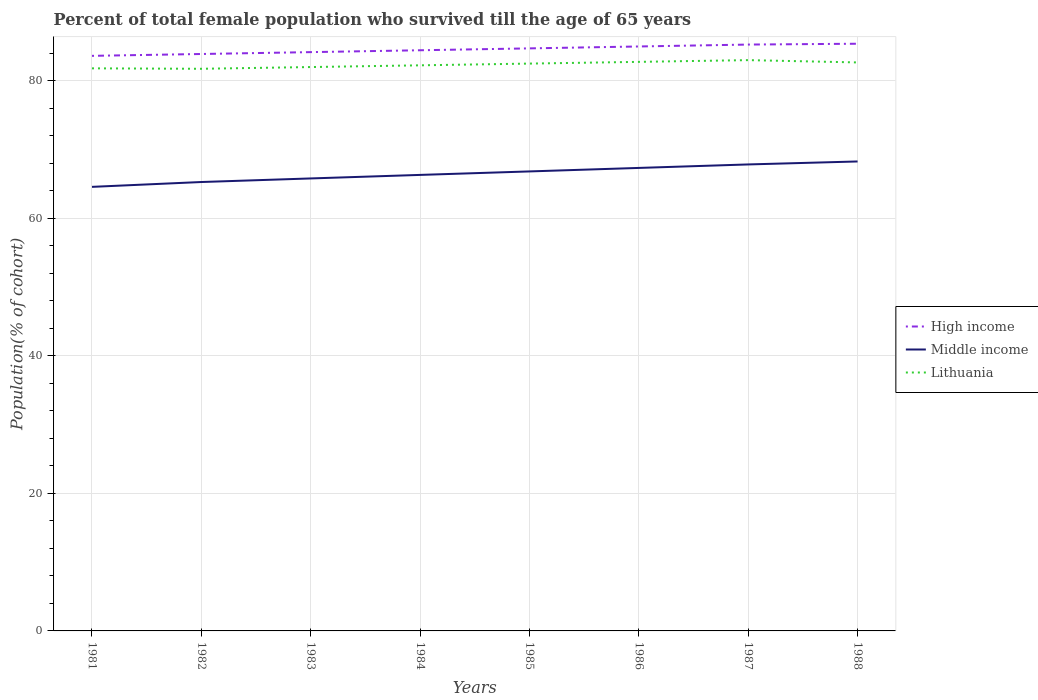Is the number of lines equal to the number of legend labels?
Provide a succinct answer. Yes. Across all years, what is the maximum percentage of total female population who survived till the age of 65 years in High income?
Your response must be concise. 83.59. What is the total percentage of total female population who survived till the age of 65 years in Lithuania in the graph?
Keep it short and to the point. -0.44. What is the difference between the highest and the second highest percentage of total female population who survived till the age of 65 years in High income?
Your answer should be compact. 1.76. What is the difference between the highest and the lowest percentage of total female population who survived till the age of 65 years in Middle income?
Ensure brevity in your answer.  4. Is the percentage of total female population who survived till the age of 65 years in Lithuania strictly greater than the percentage of total female population who survived till the age of 65 years in High income over the years?
Offer a terse response. Yes. How many years are there in the graph?
Provide a short and direct response. 8. What is the difference between two consecutive major ticks on the Y-axis?
Your answer should be compact. 20. Are the values on the major ticks of Y-axis written in scientific E-notation?
Give a very brief answer. No. Does the graph contain any zero values?
Make the answer very short. No. Does the graph contain grids?
Provide a short and direct response. Yes. Where does the legend appear in the graph?
Your answer should be very brief. Center right. How many legend labels are there?
Ensure brevity in your answer.  3. How are the legend labels stacked?
Provide a succinct answer. Vertical. What is the title of the graph?
Provide a succinct answer. Percent of total female population who survived till the age of 65 years. What is the label or title of the Y-axis?
Offer a terse response. Population(% of cohort). What is the Population(% of cohort) of High income in 1981?
Your answer should be very brief. 83.59. What is the Population(% of cohort) in Middle income in 1981?
Your response must be concise. 64.55. What is the Population(% of cohort) of Lithuania in 1981?
Provide a short and direct response. 81.77. What is the Population(% of cohort) in High income in 1982?
Your answer should be compact. 83.86. What is the Population(% of cohort) of Middle income in 1982?
Your answer should be very brief. 65.25. What is the Population(% of cohort) in Lithuania in 1982?
Make the answer very short. 81.71. What is the Population(% of cohort) of High income in 1983?
Offer a terse response. 84.13. What is the Population(% of cohort) of Middle income in 1983?
Provide a short and direct response. 65.77. What is the Population(% of cohort) in Lithuania in 1983?
Keep it short and to the point. 81.96. What is the Population(% of cohort) of High income in 1984?
Give a very brief answer. 84.4. What is the Population(% of cohort) in Middle income in 1984?
Give a very brief answer. 66.29. What is the Population(% of cohort) of Lithuania in 1984?
Your response must be concise. 82.22. What is the Population(% of cohort) in High income in 1985?
Your answer should be very brief. 84.68. What is the Population(% of cohort) of Middle income in 1985?
Make the answer very short. 66.79. What is the Population(% of cohort) in Lithuania in 1985?
Offer a terse response. 82.47. What is the Population(% of cohort) in High income in 1986?
Offer a very short reply. 84.96. What is the Population(% of cohort) of Middle income in 1986?
Provide a succinct answer. 67.3. What is the Population(% of cohort) of Lithuania in 1986?
Your answer should be very brief. 82.72. What is the Population(% of cohort) in High income in 1987?
Offer a terse response. 85.23. What is the Population(% of cohort) of Middle income in 1987?
Your answer should be compact. 67.81. What is the Population(% of cohort) in Lithuania in 1987?
Your answer should be compact. 82.97. What is the Population(% of cohort) in High income in 1988?
Your answer should be very brief. 85.35. What is the Population(% of cohort) in Middle income in 1988?
Provide a succinct answer. 68.24. What is the Population(% of cohort) of Lithuania in 1988?
Provide a short and direct response. 82.64. Across all years, what is the maximum Population(% of cohort) in High income?
Provide a succinct answer. 85.35. Across all years, what is the maximum Population(% of cohort) in Middle income?
Provide a short and direct response. 68.24. Across all years, what is the maximum Population(% of cohort) of Lithuania?
Offer a very short reply. 82.97. Across all years, what is the minimum Population(% of cohort) in High income?
Give a very brief answer. 83.59. Across all years, what is the minimum Population(% of cohort) of Middle income?
Make the answer very short. 64.55. Across all years, what is the minimum Population(% of cohort) of Lithuania?
Ensure brevity in your answer.  81.71. What is the total Population(% of cohort) in High income in the graph?
Give a very brief answer. 676.21. What is the total Population(% of cohort) in Middle income in the graph?
Give a very brief answer. 532. What is the total Population(% of cohort) in Lithuania in the graph?
Offer a terse response. 658.46. What is the difference between the Population(% of cohort) of High income in 1981 and that in 1982?
Keep it short and to the point. -0.27. What is the difference between the Population(% of cohort) in Middle income in 1981 and that in 1982?
Give a very brief answer. -0.7. What is the difference between the Population(% of cohort) of Lithuania in 1981 and that in 1982?
Provide a short and direct response. 0.06. What is the difference between the Population(% of cohort) of High income in 1981 and that in 1983?
Give a very brief answer. -0.54. What is the difference between the Population(% of cohort) in Middle income in 1981 and that in 1983?
Your answer should be compact. -1.23. What is the difference between the Population(% of cohort) of Lithuania in 1981 and that in 1983?
Provide a short and direct response. -0.19. What is the difference between the Population(% of cohort) of High income in 1981 and that in 1984?
Provide a short and direct response. -0.81. What is the difference between the Population(% of cohort) in Middle income in 1981 and that in 1984?
Keep it short and to the point. -1.74. What is the difference between the Population(% of cohort) in Lithuania in 1981 and that in 1984?
Make the answer very short. -0.44. What is the difference between the Population(% of cohort) of High income in 1981 and that in 1985?
Your answer should be very brief. -1.09. What is the difference between the Population(% of cohort) of Middle income in 1981 and that in 1985?
Make the answer very short. -2.24. What is the difference between the Population(% of cohort) in Lithuania in 1981 and that in 1985?
Ensure brevity in your answer.  -0.69. What is the difference between the Population(% of cohort) of High income in 1981 and that in 1986?
Your answer should be very brief. -1.36. What is the difference between the Population(% of cohort) in Middle income in 1981 and that in 1986?
Your response must be concise. -2.75. What is the difference between the Population(% of cohort) of Lithuania in 1981 and that in 1986?
Make the answer very short. -0.94. What is the difference between the Population(% of cohort) of High income in 1981 and that in 1987?
Keep it short and to the point. -1.64. What is the difference between the Population(% of cohort) of Middle income in 1981 and that in 1987?
Offer a very short reply. -3.26. What is the difference between the Population(% of cohort) in Lithuania in 1981 and that in 1987?
Offer a very short reply. -1.2. What is the difference between the Population(% of cohort) in High income in 1981 and that in 1988?
Your answer should be compact. -1.76. What is the difference between the Population(% of cohort) of Middle income in 1981 and that in 1988?
Provide a short and direct response. -3.69. What is the difference between the Population(% of cohort) in Lithuania in 1981 and that in 1988?
Your answer should be very brief. -0.86. What is the difference between the Population(% of cohort) of High income in 1982 and that in 1983?
Make the answer very short. -0.27. What is the difference between the Population(% of cohort) of Middle income in 1982 and that in 1983?
Provide a short and direct response. -0.52. What is the difference between the Population(% of cohort) in Lithuania in 1982 and that in 1983?
Provide a succinct answer. -0.25. What is the difference between the Population(% of cohort) in High income in 1982 and that in 1984?
Your response must be concise. -0.54. What is the difference between the Population(% of cohort) of Middle income in 1982 and that in 1984?
Your answer should be very brief. -1.03. What is the difference between the Population(% of cohort) of Lithuania in 1982 and that in 1984?
Provide a short and direct response. -0.5. What is the difference between the Population(% of cohort) in High income in 1982 and that in 1985?
Ensure brevity in your answer.  -0.82. What is the difference between the Population(% of cohort) of Middle income in 1982 and that in 1985?
Your answer should be very brief. -1.54. What is the difference between the Population(% of cohort) of Lithuania in 1982 and that in 1985?
Offer a terse response. -0.75. What is the difference between the Population(% of cohort) in High income in 1982 and that in 1986?
Your answer should be compact. -1.09. What is the difference between the Population(% of cohort) of Middle income in 1982 and that in 1986?
Make the answer very short. -2.05. What is the difference between the Population(% of cohort) of Lithuania in 1982 and that in 1986?
Keep it short and to the point. -1.01. What is the difference between the Population(% of cohort) of High income in 1982 and that in 1987?
Keep it short and to the point. -1.37. What is the difference between the Population(% of cohort) in Middle income in 1982 and that in 1987?
Your answer should be compact. -2.55. What is the difference between the Population(% of cohort) of Lithuania in 1982 and that in 1987?
Provide a short and direct response. -1.26. What is the difference between the Population(% of cohort) in High income in 1982 and that in 1988?
Provide a short and direct response. -1.49. What is the difference between the Population(% of cohort) of Middle income in 1982 and that in 1988?
Offer a terse response. -2.99. What is the difference between the Population(% of cohort) in Lithuania in 1982 and that in 1988?
Your answer should be compact. -0.92. What is the difference between the Population(% of cohort) in High income in 1983 and that in 1984?
Offer a terse response. -0.27. What is the difference between the Population(% of cohort) of Middle income in 1983 and that in 1984?
Ensure brevity in your answer.  -0.51. What is the difference between the Population(% of cohort) of Lithuania in 1983 and that in 1984?
Ensure brevity in your answer.  -0.25. What is the difference between the Population(% of cohort) in High income in 1983 and that in 1985?
Offer a terse response. -0.55. What is the difference between the Population(% of cohort) in Middle income in 1983 and that in 1985?
Give a very brief answer. -1.02. What is the difference between the Population(% of cohort) of Lithuania in 1983 and that in 1985?
Your answer should be very brief. -0.5. What is the difference between the Population(% of cohort) in High income in 1983 and that in 1986?
Your answer should be very brief. -0.82. What is the difference between the Population(% of cohort) of Middle income in 1983 and that in 1986?
Provide a succinct answer. -1.53. What is the difference between the Population(% of cohort) of Lithuania in 1983 and that in 1986?
Ensure brevity in your answer.  -0.75. What is the difference between the Population(% of cohort) in High income in 1983 and that in 1987?
Your answer should be compact. -1.1. What is the difference between the Population(% of cohort) of Middle income in 1983 and that in 1987?
Your answer should be compact. -2.03. What is the difference between the Population(% of cohort) of Lithuania in 1983 and that in 1987?
Offer a terse response. -1.01. What is the difference between the Population(% of cohort) of High income in 1983 and that in 1988?
Your answer should be very brief. -1.22. What is the difference between the Population(% of cohort) of Middle income in 1983 and that in 1988?
Offer a terse response. -2.47. What is the difference between the Population(% of cohort) in Lithuania in 1983 and that in 1988?
Your answer should be very brief. -0.67. What is the difference between the Population(% of cohort) in High income in 1984 and that in 1985?
Offer a terse response. -0.27. What is the difference between the Population(% of cohort) in Middle income in 1984 and that in 1985?
Make the answer very short. -0.51. What is the difference between the Population(% of cohort) in Lithuania in 1984 and that in 1985?
Your response must be concise. -0.25. What is the difference between the Population(% of cohort) in High income in 1984 and that in 1986?
Provide a short and direct response. -0.55. What is the difference between the Population(% of cohort) of Middle income in 1984 and that in 1986?
Make the answer very short. -1.02. What is the difference between the Population(% of cohort) in Lithuania in 1984 and that in 1986?
Your response must be concise. -0.5. What is the difference between the Population(% of cohort) in High income in 1984 and that in 1987?
Provide a succinct answer. -0.83. What is the difference between the Population(% of cohort) of Middle income in 1984 and that in 1987?
Ensure brevity in your answer.  -1.52. What is the difference between the Population(% of cohort) in Lithuania in 1984 and that in 1987?
Your answer should be compact. -0.75. What is the difference between the Population(% of cohort) in High income in 1984 and that in 1988?
Give a very brief answer. -0.95. What is the difference between the Population(% of cohort) in Middle income in 1984 and that in 1988?
Your answer should be compact. -1.96. What is the difference between the Population(% of cohort) of Lithuania in 1984 and that in 1988?
Your response must be concise. -0.42. What is the difference between the Population(% of cohort) in High income in 1985 and that in 1986?
Keep it short and to the point. -0.28. What is the difference between the Population(% of cohort) in Middle income in 1985 and that in 1986?
Ensure brevity in your answer.  -0.51. What is the difference between the Population(% of cohort) in Lithuania in 1985 and that in 1986?
Your response must be concise. -0.25. What is the difference between the Population(% of cohort) in High income in 1985 and that in 1987?
Your answer should be compact. -0.55. What is the difference between the Population(% of cohort) in Middle income in 1985 and that in 1987?
Your response must be concise. -1.01. What is the difference between the Population(% of cohort) of Lithuania in 1985 and that in 1987?
Your response must be concise. -0.5. What is the difference between the Population(% of cohort) in High income in 1985 and that in 1988?
Your response must be concise. -0.68. What is the difference between the Population(% of cohort) of Middle income in 1985 and that in 1988?
Ensure brevity in your answer.  -1.45. What is the difference between the Population(% of cohort) of Lithuania in 1985 and that in 1988?
Make the answer very short. -0.17. What is the difference between the Population(% of cohort) of High income in 1986 and that in 1987?
Offer a very short reply. -0.28. What is the difference between the Population(% of cohort) of Middle income in 1986 and that in 1987?
Your response must be concise. -0.5. What is the difference between the Population(% of cohort) of Lithuania in 1986 and that in 1987?
Your response must be concise. -0.25. What is the difference between the Population(% of cohort) in High income in 1986 and that in 1988?
Ensure brevity in your answer.  -0.4. What is the difference between the Population(% of cohort) in Middle income in 1986 and that in 1988?
Provide a short and direct response. -0.94. What is the difference between the Population(% of cohort) in Lithuania in 1986 and that in 1988?
Give a very brief answer. 0.08. What is the difference between the Population(% of cohort) of High income in 1987 and that in 1988?
Keep it short and to the point. -0.12. What is the difference between the Population(% of cohort) of Middle income in 1987 and that in 1988?
Provide a short and direct response. -0.43. What is the difference between the Population(% of cohort) in Lithuania in 1987 and that in 1988?
Ensure brevity in your answer.  0.33. What is the difference between the Population(% of cohort) of High income in 1981 and the Population(% of cohort) of Middle income in 1982?
Your answer should be compact. 18.34. What is the difference between the Population(% of cohort) of High income in 1981 and the Population(% of cohort) of Lithuania in 1982?
Offer a very short reply. 1.88. What is the difference between the Population(% of cohort) in Middle income in 1981 and the Population(% of cohort) in Lithuania in 1982?
Make the answer very short. -17.16. What is the difference between the Population(% of cohort) in High income in 1981 and the Population(% of cohort) in Middle income in 1983?
Make the answer very short. 17.82. What is the difference between the Population(% of cohort) in High income in 1981 and the Population(% of cohort) in Lithuania in 1983?
Your answer should be very brief. 1.63. What is the difference between the Population(% of cohort) of Middle income in 1981 and the Population(% of cohort) of Lithuania in 1983?
Offer a terse response. -17.42. What is the difference between the Population(% of cohort) of High income in 1981 and the Population(% of cohort) of Middle income in 1984?
Offer a very short reply. 17.31. What is the difference between the Population(% of cohort) of High income in 1981 and the Population(% of cohort) of Lithuania in 1984?
Your answer should be compact. 1.38. What is the difference between the Population(% of cohort) in Middle income in 1981 and the Population(% of cohort) in Lithuania in 1984?
Provide a succinct answer. -17.67. What is the difference between the Population(% of cohort) of High income in 1981 and the Population(% of cohort) of Middle income in 1985?
Your answer should be compact. 16.8. What is the difference between the Population(% of cohort) in High income in 1981 and the Population(% of cohort) in Lithuania in 1985?
Ensure brevity in your answer.  1.13. What is the difference between the Population(% of cohort) in Middle income in 1981 and the Population(% of cohort) in Lithuania in 1985?
Keep it short and to the point. -17.92. What is the difference between the Population(% of cohort) in High income in 1981 and the Population(% of cohort) in Middle income in 1986?
Ensure brevity in your answer.  16.29. What is the difference between the Population(% of cohort) of High income in 1981 and the Population(% of cohort) of Lithuania in 1986?
Give a very brief answer. 0.87. What is the difference between the Population(% of cohort) of Middle income in 1981 and the Population(% of cohort) of Lithuania in 1986?
Ensure brevity in your answer.  -18.17. What is the difference between the Population(% of cohort) in High income in 1981 and the Population(% of cohort) in Middle income in 1987?
Offer a very short reply. 15.79. What is the difference between the Population(% of cohort) in High income in 1981 and the Population(% of cohort) in Lithuania in 1987?
Make the answer very short. 0.62. What is the difference between the Population(% of cohort) of Middle income in 1981 and the Population(% of cohort) of Lithuania in 1987?
Ensure brevity in your answer.  -18.42. What is the difference between the Population(% of cohort) in High income in 1981 and the Population(% of cohort) in Middle income in 1988?
Your response must be concise. 15.35. What is the difference between the Population(% of cohort) in High income in 1981 and the Population(% of cohort) in Lithuania in 1988?
Keep it short and to the point. 0.96. What is the difference between the Population(% of cohort) in Middle income in 1981 and the Population(% of cohort) in Lithuania in 1988?
Provide a succinct answer. -18.09. What is the difference between the Population(% of cohort) in High income in 1982 and the Population(% of cohort) in Middle income in 1983?
Keep it short and to the point. 18.09. What is the difference between the Population(% of cohort) of High income in 1982 and the Population(% of cohort) of Lithuania in 1983?
Provide a succinct answer. 1.9. What is the difference between the Population(% of cohort) in Middle income in 1982 and the Population(% of cohort) in Lithuania in 1983?
Provide a succinct answer. -16.71. What is the difference between the Population(% of cohort) of High income in 1982 and the Population(% of cohort) of Middle income in 1984?
Offer a terse response. 17.58. What is the difference between the Population(% of cohort) in High income in 1982 and the Population(% of cohort) in Lithuania in 1984?
Give a very brief answer. 1.65. What is the difference between the Population(% of cohort) of Middle income in 1982 and the Population(% of cohort) of Lithuania in 1984?
Your answer should be very brief. -16.96. What is the difference between the Population(% of cohort) of High income in 1982 and the Population(% of cohort) of Middle income in 1985?
Your response must be concise. 17.07. What is the difference between the Population(% of cohort) of High income in 1982 and the Population(% of cohort) of Lithuania in 1985?
Your response must be concise. 1.39. What is the difference between the Population(% of cohort) in Middle income in 1982 and the Population(% of cohort) in Lithuania in 1985?
Keep it short and to the point. -17.21. What is the difference between the Population(% of cohort) of High income in 1982 and the Population(% of cohort) of Middle income in 1986?
Ensure brevity in your answer.  16.56. What is the difference between the Population(% of cohort) of High income in 1982 and the Population(% of cohort) of Lithuania in 1986?
Your answer should be compact. 1.14. What is the difference between the Population(% of cohort) in Middle income in 1982 and the Population(% of cohort) in Lithuania in 1986?
Your answer should be very brief. -17.47. What is the difference between the Population(% of cohort) in High income in 1982 and the Population(% of cohort) in Middle income in 1987?
Your answer should be compact. 16.05. What is the difference between the Population(% of cohort) in High income in 1982 and the Population(% of cohort) in Lithuania in 1987?
Offer a terse response. 0.89. What is the difference between the Population(% of cohort) in Middle income in 1982 and the Population(% of cohort) in Lithuania in 1987?
Keep it short and to the point. -17.72. What is the difference between the Population(% of cohort) in High income in 1982 and the Population(% of cohort) in Middle income in 1988?
Ensure brevity in your answer.  15.62. What is the difference between the Population(% of cohort) in High income in 1982 and the Population(% of cohort) in Lithuania in 1988?
Provide a succinct answer. 1.23. What is the difference between the Population(% of cohort) of Middle income in 1982 and the Population(% of cohort) of Lithuania in 1988?
Your response must be concise. -17.38. What is the difference between the Population(% of cohort) in High income in 1983 and the Population(% of cohort) in Middle income in 1984?
Offer a very short reply. 17.85. What is the difference between the Population(% of cohort) in High income in 1983 and the Population(% of cohort) in Lithuania in 1984?
Ensure brevity in your answer.  1.92. What is the difference between the Population(% of cohort) in Middle income in 1983 and the Population(% of cohort) in Lithuania in 1984?
Your response must be concise. -16.44. What is the difference between the Population(% of cohort) of High income in 1983 and the Population(% of cohort) of Middle income in 1985?
Keep it short and to the point. 17.34. What is the difference between the Population(% of cohort) in High income in 1983 and the Population(% of cohort) in Lithuania in 1985?
Keep it short and to the point. 1.67. What is the difference between the Population(% of cohort) of Middle income in 1983 and the Population(% of cohort) of Lithuania in 1985?
Offer a terse response. -16.69. What is the difference between the Population(% of cohort) of High income in 1983 and the Population(% of cohort) of Middle income in 1986?
Ensure brevity in your answer.  16.83. What is the difference between the Population(% of cohort) in High income in 1983 and the Population(% of cohort) in Lithuania in 1986?
Keep it short and to the point. 1.41. What is the difference between the Population(% of cohort) of Middle income in 1983 and the Population(% of cohort) of Lithuania in 1986?
Your answer should be very brief. -16.95. What is the difference between the Population(% of cohort) in High income in 1983 and the Population(% of cohort) in Middle income in 1987?
Give a very brief answer. 16.33. What is the difference between the Population(% of cohort) in High income in 1983 and the Population(% of cohort) in Lithuania in 1987?
Make the answer very short. 1.16. What is the difference between the Population(% of cohort) in Middle income in 1983 and the Population(% of cohort) in Lithuania in 1987?
Ensure brevity in your answer.  -17.2. What is the difference between the Population(% of cohort) of High income in 1983 and the Population(% of cohort) of Middle income in 1988?
Your response must be concise. 15.89. What is the difference between the Population(% of cohort) of High income in 1983 and the Population(% of cohort) of Lithuania in 1988?
Offer a very short reply. 1.5. What is the difference between the Population(% of cohort) in Middle income in 1983 and the Population(% of cohort) in Lithuania in 1988?
Provide a short and direct response. -16.86. What is the difference between the Population(% of cohort) of High income in 1984 and the Population(% of cohort) of Middle income in 1985?
Offer a very short reply. 17.61. What is the difference between the Population(% of cohort) in High income in 1984 and the Population(% of cohort) in Lithuania in 1985?
Keep it short and to the point. 1.94. What is the difference between the Population(% of cohort) in Middle income in 1984 and the Population(% of cohort) in Lithuania in 1985?
Provide a succinct answer. -16.18. What is the difference between the Population(% of cohort) in High income in 1984 and the Population(% of cohort) in Middle income in 1986?
Offer a very short reply. 17.1. What is the difference between the Population(% of cohort) in High income in 1984 and the Population(% of cohort) in Lithuania in 1986?
Make the answer very short. 1.69. What is the difference between the Population(% of cohort) of Middle income in 1984 and the Population(% of cohort) of Lithuania in 1986?
Offer a very short reply. -16.43. What is the difference between the Population(% of cohort) of High income in 1984 and the Population(% of cohort) of Middle income in 1987?
Your answer should be compact. 16.6. What is the difference between the Population(% of cohort) in High income in 1984 and the Population(% of cohort) in Lithuania in 1987?
Make the answer very short. 1.43. What is the difference between the Population(% of cohort) in Middle income in 1984 and the Population(% of cohort) in Lithuania in 1987?
Your answer should be compact. -16.68. What is the difference between the Population(% of cohort) of High income in 1984 and the Population(% of cohort) of Middle income in 1988?
Your response must be concise. 16.16. What is the difference between the Population(% of cohort) in High income in 1984 and the Population(% of cohort) in Lithuania in 1988?
Your answer should be compact. 1.77. What is the difference between the Population(% of cohort) in Middle income in 1984 and the Population(% of cohort) in Lithuania in 1988?
Your answer should be very brief. -16.35. What is the difference between the Population(% of cohort) in High income in 1985 and the Population(% of cohort) in Middle income in 1986?
Offer a terse response. 17.38. What is the difference between the Population(% of cohort) of High income in 1985 and the Population(% of cohort) of Lithuania in 1986?
Keep it short and to the point. 1.96. What is the difference between the Population(% of cohort) of Middle income in 1985 and the Population(% of cohort) of Lithuania in 1986?
Ensure brevity in your answer.  -15.93. What is the difference between the Population(% of cohort) in High income in 1985 and the Population(% of cohort) in Middle income in 1987?
Your response must be concise. 16.87. What is the difference between the Population(% of cohort) in High income in 1985 and the Population(% of cohort) in Lithuania in 1987?
Ensure brevity in your answer.  1.71. What is the difference between the Population(% of cohort) of Middle income in 1985 and the Population(% of cohort) of Lithuania in 1987?
Your response must be concise. -16.18. What is the difference between the Population(% of cohort) in High income in 1985 and the Population(% of cohort) in Middle income in 1988?
Your response must be concise. 16.44. What is the difference between the Population(% of cohort) of High income in 1985 and the Population(% of cohort) of Lithuania in 1988?
Provide a succinct answer. 2.04. What is the difference between the Population(% of cohort) in Middle income in 1985 and the Population(% of cohort) in Lithuania in 1988?
Provide a succinct answer. -15.84. What is the difference between the Population(% of cohort) in High income in 1986 and the Population(% of cohort) in Middle income in 1987?
Provide a succinct answer. 17.15. What is the difference between the Population(% of cohort) of High income in 1986 and the Population(% of cohort) of Lithuania in 1987?
Offer a terse response. 1.98. What is the difference between the Population(% of cohort) of Middle income in 1986 and the Population(% of cohort) of Lithuania in 1987?
Provide a succinct answer. -15.67. What is the difference between the Population(% of cohort) in High income in 1986 and the Population(% of cohort) in Middle income in 1988?
Offer a terse response. 16.71. What is the difference between the Population(% of cohort) of High income in 1986 and the Population(% of cohort) of Lithuania in 1988?
Your answer should be compact. 2.32. What is the difference between the Population(% of cohort) of Middle income in 1986 and the Population(% of cohort) of Lithuania in 1988?
Your response must be concise. -15.33. What is the difference between the Population(% of cohort) of High income in 1987 and the Population(% of cohort) of Middle income in 1988?
Keep it short and to the point. 16.99. What is the difference between the Population(% of cohort) in High income in 1987 and the Population(% of cohort) in Lithuania in 1988?
Ensure brevity in your answer.  2.6. What is the difference between the Population(% of cohort) of Middle income in 1987 and the Population(% of cohort) of Lithuania in 1988?
Your answer should be compact. -14.83. What is the average Population(% of cohort) of High income per year?
Provide a short and direct response. 84.53. What is the average Population(% of cohort) of Middle income per year?
Offer a very short reply. 66.5. What is the average Population(% of cohort) in Lithuania per year?
Give a very brief answer. 82.31. In the year 1981, what is the difference between the Population(% of cohort) in High income and Population(% of cohort) in Middle income?
Provide a short and direct response. 19.04. In the year 1981, what is the difference between the Population(% of cohort) in High income and Population(% of cohort) in Lithuania?
Provide a succinct answer. 1.82. In the year 1981, what is the difference between the Population(% of cohort) of Middle income and Population(% of cohort) of Lithuania?
Provide a succinct answer. -17.23. In the year 1982, what is the difference between the Population(% of cohort) in High income and Population(% of cohort) in Middle income?
Make the answer very short. 18.61. In the year 1982, what is the difference between the Population(% of cohort) of High income and Population(% of cohort) of Lithuania?
Your answer should be very brief. 2.15. In the year 1982, what is the difference between the Population(% of cohort) in Middle income and Population(% of cohort) in Lithuania?
Make the answer very short. -16.46. In the year 1983, what is the difference between the Population(% of cohort) of High income and Population(% of cohort) of Middle income?
Provide a succinct answer. 18.36. In the year 1983, what is the difference between the Population(% of cohort) in High income and Population(% of cohort) in Lithuania?
Provide a short and direct response. 2.17. In the year 1983, what is the difference between the Population(% of cohort) in Middle income and Population(% of cohort) in Lithuania?
Offer a terse response. -16.19. In the year 1984, what is the difference between the Population(% of cohort) of High income and Population(% of cohort) of Middle income?
Provide a succinct answer. 18.12. In the year 1984, what is the difference between the Population(% of cohort) in High income and Population(% of cohort) in Lithuania?
Your answer should be very brief. 2.19. In the year 1984, what is the difference between the Population(% of cohort) in Middle income and Population(% of cohort) in Lithuania?
Offer a terse response. -15.93. In the year 1985, what is the difference between the Population(% of cohort) in High income and Population(% of cohort) in Middle income?
Provide a short and direct response. 17.89. In the year 1985, what is the difference between the Population(% of cohort) of High income and Population(% of cohort) of Lithuania?
Offer a very short reply. 2.21. In the year 1985, what is the difference between the Population(% of cohort) of Middle income and Population(% of cohort) of Lithuania?
Offer a very short reply. -15.67. In the year 1986, what is the difference between the Population(% of cohort) in High income and Population(% of cohort) in Middle income?
Provide a short and direct response. 17.65. In the year 1986, what is the difference between the Population(% of cohort) in High income and Population(% of cohort) in Lithuania?
Provide a short and direct response. 2.24. In the year 1986, what is the difference between the Population(% of cohort) of Middle income and Population(% of cohort) of Lithuania?
Provide a succinct answer. -15.42. In the year 1987, what is the difference between the Population(% of cohort) of High income and Population(% of cohort) of Middle income?
Give a very brief answer. 17.43. In the year 1987, what is the difference between the Population(% of cohort) in High income and Population(% of cohort) in Lithuania?
Keep it short and to the point. 2.26. In the year 1987, what is the difference between the Population(% of cohort) of Middle income and Population(% of cohort) of Lithuania?
Offer a terse response. -15.16. In the year 1988, what is the difference between the Population(% of cohort) of High income and Population(% of cohort) of Middle income?
Provide a succinct answer. 17.11. In the year 1988, what is the difference between the Population(% of cohort) of High income and Population(% of cohort) of Lithuania?
Make the answer very short. 2.72. In the year 1988, what is the difference between the Population(% of cohort) in Middle income and Population(% of cohort) in Lithuania?
Provide a succinct answer. -14.39. What is the ratio of the Population(% of cohort) of High income in 1981 to that in 1982?
Your response must be concise. 1. What is the ratio of the Population(% of cohort) in Middle income in 1981 to that in 1982?
Make the answer very short. 0.99. What is the ratio of the Population(% of cohort) of Lithuania in 1981 to that in 1982?
Provide a succinct answer. 1. What is the ratio of the Population(% of cohort) of High income in 1981 to that in 1983?
Offer a very short reply. 0.99. What is the ratio of the Population(% of cohort) in Middle income in 1981 to that in 1983?
Your answer should be very brief. 0.98. What is the ratio of the Population(% of cohort) in Middle income in 1981 to that in 1984?
Ensure brevity in your answer.  0.97. What is the ratio of the Population(% of cohort) in Lithuania in 1981 to that in 1984?
Offer a very short reply. 0.99. What is the ratio of the Population(% of cohort) in High income in 1981 to that in 1985?
Keep it short and to the point. 0.99. What is the ratio of the Population(% of cohort) of Middle income in 1981 to that in 1985?
Ensure brevity in your answer.  0.97. What is the ratio of the Population(% of cohort) in Middle income in 1981 to that in 1986?
Your answer should be compact. 0.96. What is the ratio of the Population(% of cohort) in Lithuania in 1981 to that in 1986?
Offer a very short reply. 0.99. What is the ratio of the Population(% of cohort) of High income in 1981 to that in 1987?
Your answer should be very brief. 0.98. What is the ratio of the Population(% of cohort) in Middle income in 1981 to that in 1987?
Provide a succinct answer. 0.95. What is the ratio of the Population(% of cohort) of Lithuania in 1981 to that in 1987?
Provide a succinct answer. 0.99. What is the ratio of the Population(% of cohort) of High income in 1981 to that in 1988?
Offer a very short reply. 0.98. What is the ratio of the Population(% of cohort) in Middle income in 1981 to that in 1988?
Offer a terse response. 0.95. What is the ratio of the Population(% of cohort) of Lithuania in 1981 to that in 1988?
Give a very brief answer. 0.99. What is the ratio of the Population(% of cohort) in Middle income in 1982 to that in 1983?
Provide a short and direct response. 0.99. What is the ratio of the Population(% of cohort) in Middle income in 1982 to that in 1984?
Provide a short and direct response. 0.98. What is the ratio of the Population(% of cohort) of Lithuania in 1982 to that in 1985?
Provide a short and direct response. 0.99. What is the ratio of the Population(% of cohort) in High income in 1982 to that in 1986?
Make the answer very short. 0.99. What is the ratio of the Population(% of cohort) of Middle income in 1982 to that in 1986?
Ensure brevity in your answer.  0.97. What is the ratio of the Population(% of cohort) of High income in 1982 to that in 1987?
Offer a very short reply. 0.98. What is the ratio of the Population(% of cohort) of Middle income in 1982 to that in 1987?
Your answer should be compact. 0.96. What is the ratio of the Population(% of cohort) in Lithuania in 1982 to that in 1987?
Give a very brief answer. 0.98. What is the ratio of the Population(% of cohort) in High income in 1982 to that in 1988?
Provide a succinct answer. 0.98. What is the ratio of the Population(% of cohort) in Middle income in 1982 to that in 1988?
Give a very brief answer. 0.96. What is the ratio of the Population(% of cohort) in High income in 1983 to that in 1984?
Your answer should be compact. 1. What is the ratio of the Population(% of cohort) in Middle income in 1983 to that in 1984?
Provide a short and direct response. 0.99. What is the ratio of the Population(% of cohort) of Middle income in 1983 to that in 1985?
Keep it short and to the point. 0.98. What is the ratio of the Population(% of cohort) of High income in 1983 to that in 1986?
Provide a short and direct response. 0.99. What is the ratio of the Population(% of cohort) of Middle income in 1983 to that in 1986?
Provide a short and direct response. 0.98. What is the ratio of the Population(% of cohort) of Lithuania in 1983 to that in 1986?
Provide a short and direct response. 0.99. What is the ratio of the Population(% of cohort) in High income in 1983 to that in 1987?
Make the answer very short. 0.99. What is the ratio of the Population(% of cohort) of Lithuania in 1983 to that in 1987?
Offer a very short reply. 0.99. What is the ratio of the Population(% of cohort) in High income in 1983 to that in 1988?
Your answer should be very brief. 0.99. What is the ratio of the Population(% of cohort) in Middle income in 1983 to that in 1988?
Offer a terse response. 0.96. What is the ratio of the Population(% of cohort) of Middle income in 1984 to that in 1985?
Provide a short and direct response. 0.99. What is the ratio of the Population(% of cohort) in High income in 1984 to that in 1986?
Make the answer very short. 0.99. What is the ratio of the Population(% of cohort) of Middle income in 1984 to that in 1986?
Give a very brief answer. 0.98. What is the ratio of the Population(% of cohort) of High income in 1984 to that in 1987?
Your response must be concise. 0.99. What is the ratio of the Population(% of cohort) in Middle income in 1984 to that in 1987?
Provide a succinct answer. 0.98. What is the ratio of the Population(% of cohort) of Lithuania in 1984 to that in 1987?
Your response must be concise. 0.99. What is the ratio of the Population(% of cohort) of High income in 1984 to that in 1988?
Provide a succinct answer. 0.99. What is the ratio of the Population(% of cohort) of Middle income in 1984 to that in 1988?
Offer a very short reply. 0.97. What is the ratio of the Population(% of cohort) of Lithuania in 1984 to that in 1988?
Your answer should be very brief. 0.99. What is the ratio of the Population(% of cohort) of High income in 1985 to that in 1986?
Give a very brief answer. 1. What is the ratio of the Population(% of cohort) in Middle income in 1985 to that in 1986?
Provide a succinct answer. 0.99. What is the ratio of the Population(% of cohort) of Lithuania in 1985 to that in 1987?
Provide a succinct answer. 0.99. What is the ratio of the Population(% of cohort) of Middle income in 1985 to that in 1988?
Make the answer very short. 0.98. What is the ratio of the Population(% of cohort) in Lithuania in 1985 to that in 1988?
Make the answer very short. 1. What is the ratio of the Population(% of cohort) of High income in 1986 to that in 1987?
Make the answer very short. 1. What is the ratio of the Population(% of cohort) in Middle income in 1986 to that in 1987?
Keep it short and to the point. 0.99. What is the ratio of the Population(% of cohort) of Middle income in 1986 to that in 1988?
Ensure brevity in your answer.  0.99. What is the difference between the highest and the second highest Population(% of cohort) of High income?
Provide a succinct answer. 0.12. What is the difference between the highest and the second highest Population(% of cohort) of Middle income?
Provide a short and direct response. 0.43. What is the difference between the highest and the second highest Population(% of cohort) in Lithuania?
Offer a very short reply. 0.25. What is the difference between the highest and the lowest Population(% of cohort) of High income?
Offer a terse response. 1.76. What is the difference between the highest and the lowest Population(% of cohort) of Middle income?
Ensure brevity in your answer.  3.69. What is the difference between the highest and the lowest Population(% of cohort) in Lithuania?
Give a very brief answer. 1.26. 